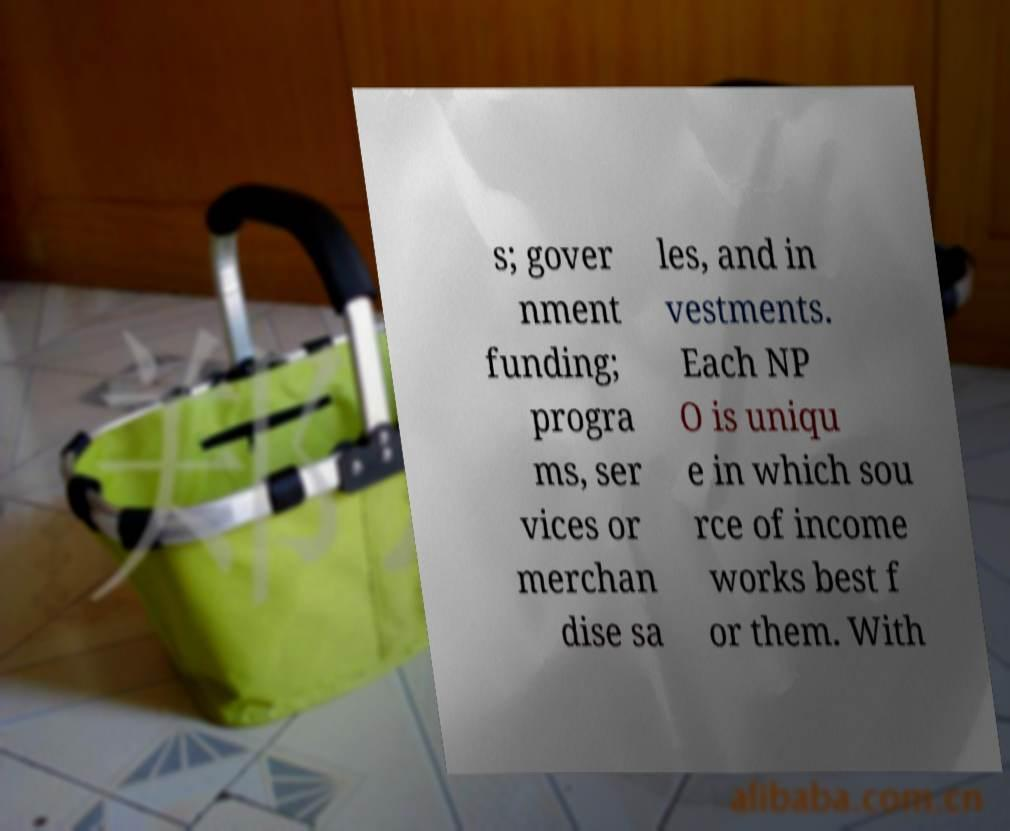Please read and relay the text visible in this image. What does it say? s; gover nment funding; progra ms, ser vices or merchan dise sa les, and in vestments. Each NP O is uniqu e in which sou rce of income works best f or them. With 